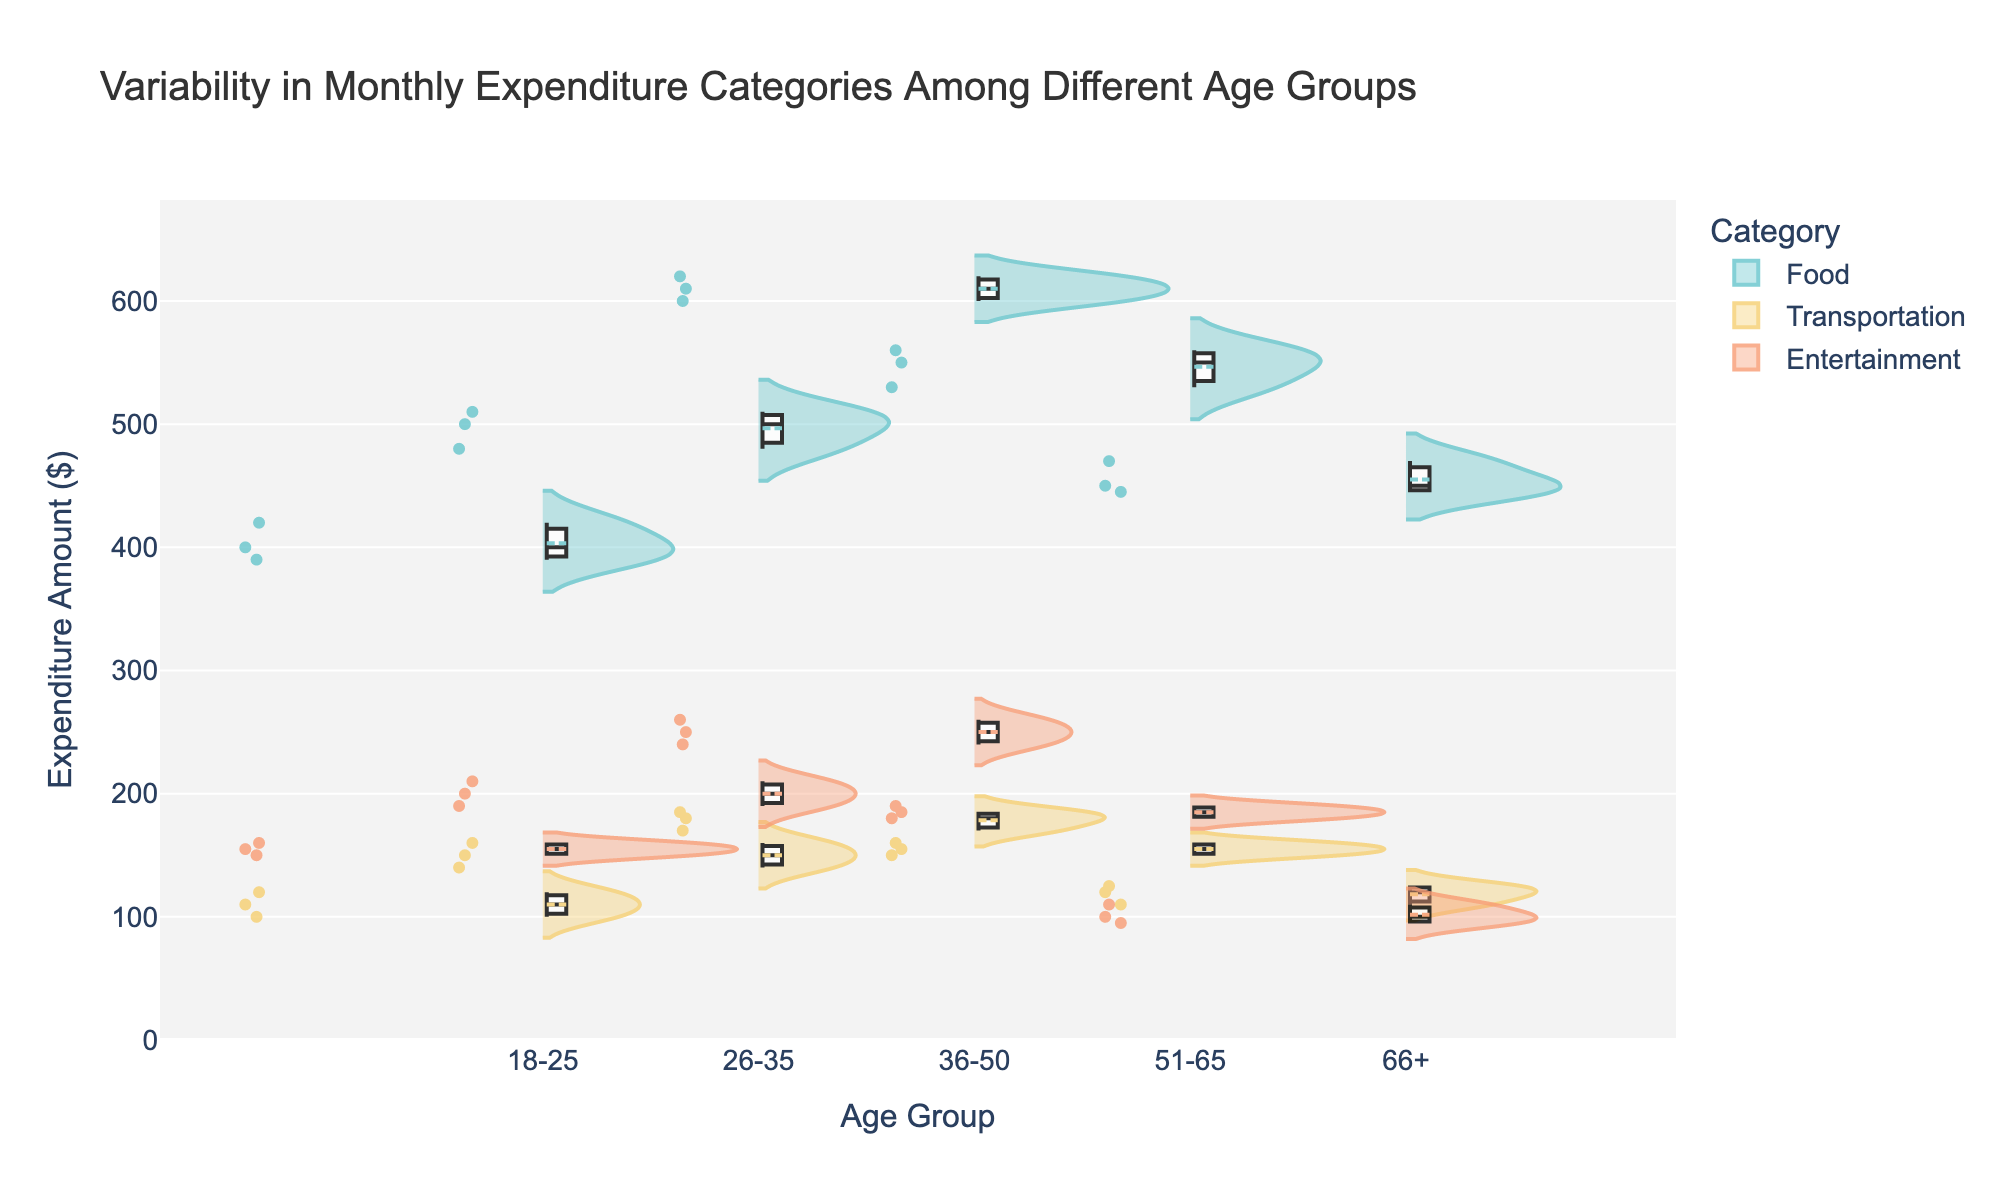What is the title of the chart? The title is usually displayed at the top of the chart and describes the overall content and purpose of the figure. In this chart, the title is "Variability in Monthly Expenditure Categories Among Different Age Groups."
Answer: Variability in Monthly Expenditure Categories Among Different Age Groups What are the age groups represented in the chart? The age groups can be identified on the x-axis, which categorizes the data into different demographic segments. The age groups are "18-25," "26-35," "36-50," "51-65," and "66+."
Answer: 18-25, 26-35, 36-50, 51-65, 66+ Which expenditure category shows the highest variability in the 26-35 age group? Variability can be assessed by observing the spread of the data in the violin plot for each category. In the 26-35 age group, "Food" expenditure has the widest spread, indicating the highest variability.
Answer: Food What is the median expenditure amount for the "Transportation" category in the 36-50 age group? In a violin plot, the median is often indicated by a horizontal line inside the box. For the "Transportation" category in the 36-50 age group, the median amount appears to be around 180 dollars.
Answer: 180 dollars Which age group spends the most on "Entertainment" on average? To determine this, compare the center (mean) of the "Entertainment" violin plots for each age group. The 36-50 age group shows the highest average expenditure on entertainment.
Answer: 36-50 How does the variability in "Food" expenditure compare between the 18-25 and 66+ age groups? By observing the spreads of the "Food" categories in both age groups, the 18-25 group has a narrower spread compared to the 66+ group, indicating less variability in the younger group.
Answer: 18-25 has less variability than 66+ What is the range of expenditures in the "Entertainment" category for the 51-65 age group? The range is the difference between the maximum and minimum values. For the "Entertainment" category in the 51-65 age group, the expenditures range approximately from 180 to 190 dollars.
Answer: 10 dollars Which category shows the widest spread (highest variability) across all age groups? By visually comparing the spreads of all categories across the age groups, "Food" generally shows the widest spread, indicating the highest variability.
Answer: Food Is the average expenditure on "Transportation" higher in the 26-35 age group or the 66+ age group? Comparing the center points of the "Transportation" violin plots for these age groups, the 26-35 age group has a higher average expenditure on transportation.
Answer: 26-35 